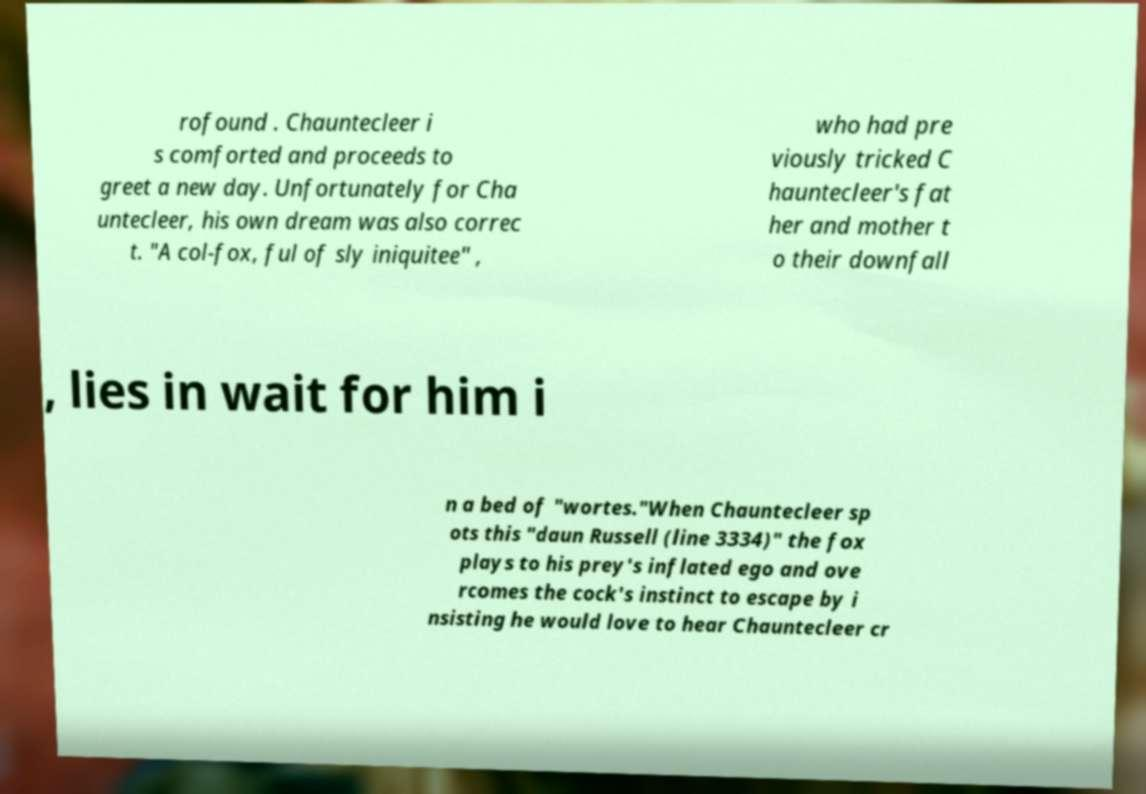Please read and relay the text visible in this image. What does it say? rofound . Chauntecleer i s comforted and proceeds to greet a new day. Unfortunately for Cha untecleer, his own dream was also correc t. "A col-fox, ful of sly iniquitee" , who had pre viously tricked C hauntecleer's fat her and mother t o their downfall , lies in wait for him i n a bed of "wortes."When Chauntecleer sp ots this "daun Russell (line 3334)" the fox plays to his prey's inflated ego and ove rcomes the cock's instinct to escape by i nsisting he would love to hear Chauntecleer cr 